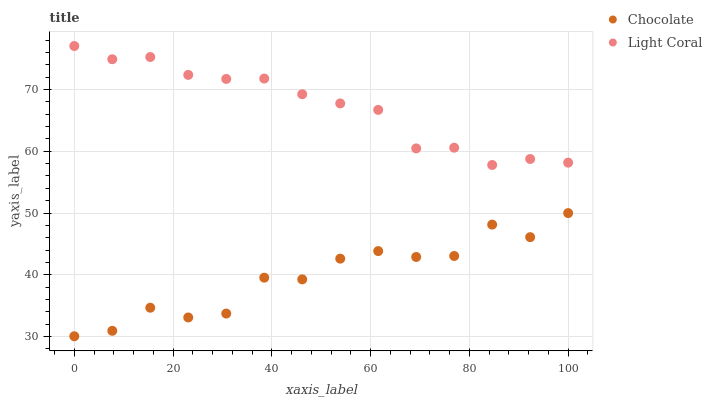Does Chocolate have the minimum area under the curve?
Answer yes or no. Yes. Does Light Coral have the maximum area under the curve?
Answer yes or no. Yes. Does Chocolate have the maximum area under the curve?
Answer yes or no. No. Is Light Coral the smoothest?
Answer yes or no. Yes. Is Chocolate the roughest?
Answer yes or no. Yes. Is Chocolate the smoothest?
Answer yes or no. No. Does Chocolate have the lowest value?
Answer yes or no. Yes. Does Light Coral have the highest value?
Answer yes or no. Yes. Does Chocolate have the highest value?
Answer yes or no. No. Is Chocolate less than Light Coral?
Answer yes or no. Yes. Is Light Coral greater than Chocolate?
Answer yes or no. Yes. Does Chocolate intersect Light Coral?
Answer yes or no. No. 